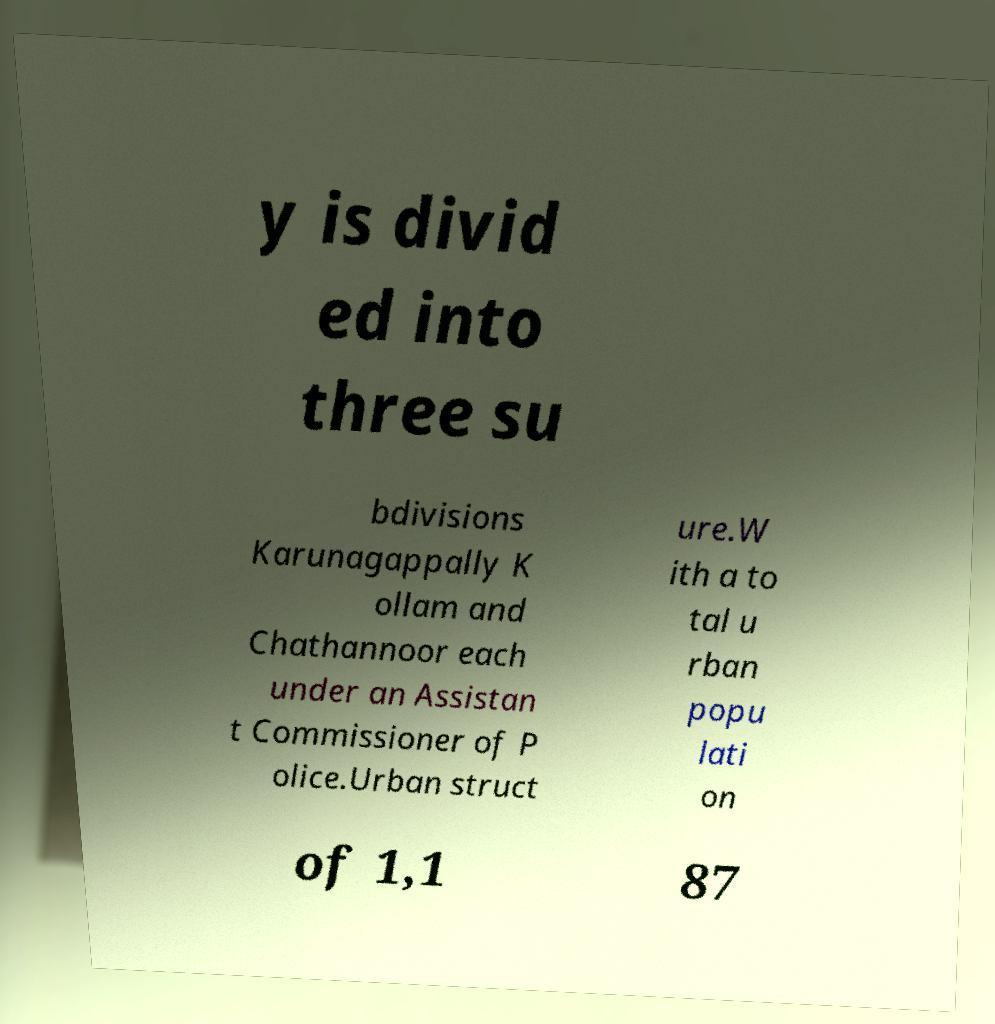Please identify and transcribe the text found in this image. y is divid ed into three su bdivisions Karunagappally K ollam and Chathannoor each under an Assistan t Commissioner of P olice.Urban struct ure.W ith a to tal u rban popu lati on of 1,1 87 